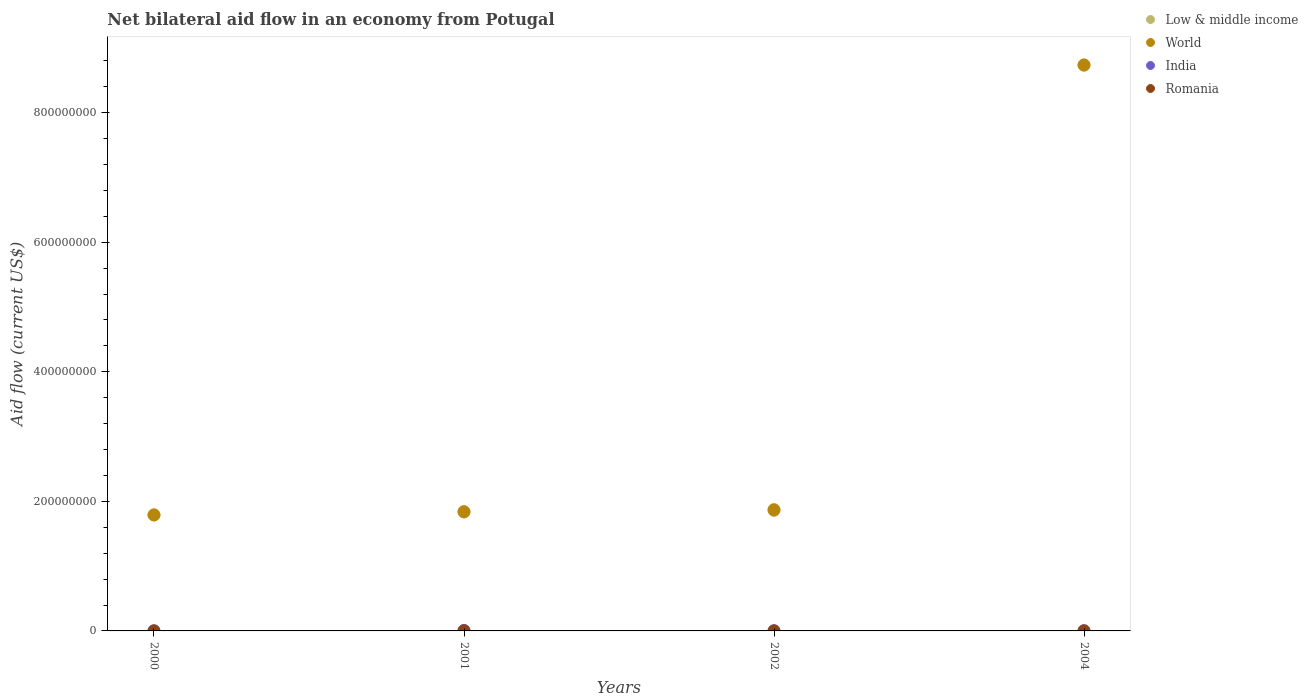How many different coloured dotlines are there?
Your answer should be compact. 4. Is the number of dotlines equal to the number of legend labels?
Provide a short and direct response. Yes. What is the net bilateral aid flow in Romania in 2001?
Your response must be concise. 1.20e+05. Across all years, what is the maximum net bilateral aid flow in Romania?
Offer a terse response. 1.20e+05. Across all years, what is the minimum net bilateral aid flow in Low & middle income?
Make the answer very short. 1.79e+08. In which year was the net bilateral aid flow in Low & middle income maximum?
Provide a short and direct response. 2004. In which year was the net bilateral aid flow in World minimum?
Your response must be concise. 2000. What is the total net bilateral aid flow in World in the graph?
Keep it short and to the point. 1.42e+09. What is the difference between the net bilateral aid flow in India in 2001 and that in 2002?
Ensure brevity in your answer.  5.40e+05. What is the difference between the net bilateral aid flow in India in 2004 and the net bilateral aid flow in Low & middle income in 2001?
Ensure brevity in your answer.  -1.83e+08. What is the average net bilateral aid flow in Low & middle income per year?
Offer a very short reply. 3.55e+08. In the year 2000, what is the difference between the net bilateral aid flow in World and net bilateral aid flow in Romania?
Your answer should be compact. 1.79e+08. In how many years, is the net bilateral aid flow in World greater than 240000000 US$?
Your answer should be compact. 1. What is the ratio of the net bilateral aid flow in Low & middle income in 2001 to that in 2004?
Your response must be concise. 0.21. Is the net bilateral aid flow in Romania in 2000 less than that in 2002?
Offer a terse response. Yes. What is the difference between the highest and the second highest net bilateral aid flow in Low & middle income?
Ensure brevity in your answer.  6.87e+08. What is the difference between the highest and the lowest net bilateral aid flow in Low & middle income?
Offer a terse response. 6.94e+08. How many years are there in the graph?
Keep it short and to the point. 4. Are the values on the major ticks of Y-axis written in scientific E-notation?
Ensure brevity in your answer.  No. Does the graph contain grids?
Offer a terse response. No. Where does the legend appear in the graph?
Keep it short and to the point. Top right. How many legend labels are there?
Make the answer very short. 4. How are the legend labels stacked?
Provide a short and direct response. Vertical. What is the title of the graph?
Provide a succinct answer. Net bilateral aid flow in an economy from Potugal. Does "Malaysia" appear as one of the legend labels in the graph?
Your answer should be very brief. No. What is the label or title of the Y-axis?
Ensure brevity in your answer.  Aid flow (current US$). What is the Aid flow (current US$) of Low & middle income in 2000?
Provide a succinct answer. 1.79e+08. What is the Aid flow (current US$) of World in 2000?
Offer a very short reply. 1.79e+08. What is the Aid flow (current US$) in India in 2000?
Provide a short and direct response. 2.40e+05. What is the Aid flow (current US$) in Low & middle income in 2001?
Give a very brief answer. 1.83e+08. What is the Aid flow (current US$) of World in 2001?
Ensure brevity in your answer.  1.84e+08. What is the Aid flow (current US$) of India in 2001?
Keep it short and to the point. 7.80e+05. What is the Aid flow (current US$) in Romania in 2001?
Ensure brevity in your answer.  1.20e+05. What is the Aid flow (current US$) in Low & middle income in 2002?
Your response must be concise. 1.86e+08. What is the Aid flow (current US$) of World in 2002?
Give a very brief answer. 1.87e+08. What is the Aid flow (current US$) of Low & middle income in 2004?
Keep it short and to the point. 8.73e+08. What is the Aid flow (current US$) of World in 2004?
Offer a very short reply. 8.74e+08. What is the Aid flow (current US$) of India in 2004?
Keep it short and to the point. 2.90e+05. Across all years, what is the maximum Aid flow (current US$) of Low & middle income?
Your response must be concise. 8.73e+08. Across all years, what is the maximum Aid flow (current US$) in World?
Your response must be concise. 8.74e+08. Across all years, what is the maximum Aid flow (current US$) of India?
Make the answer very short. 7.80e+05. Across all years, what is the minimum Aid flow (current US$) in Low & middle income?
Give a very brief answer. 1.79e+08. Across all years, what is the minimum Aid flow (current US$) of World?
Offer a very short reply. 1.79e+08. What is the total Aid flow (current US$) in Low & middle income in the graph?
Make the answer very short. 1.42e+09. What is the total Aid flow (current US$) of World in the graph?
Your response must be concise. 1.42e+09. What is the total Aid flow (current US$) of India in the graph?
Make the answer very short. 1.55e+06. What is the difference between the Aid flow (current US$) of Low & middle income in 2000 and that in 2001?
Provide a short and direct response. -4.56e+06. What is the difference between the Aid flow (current US$) in World in 2000 and that in 2001?
Keep it short and to the point. -4.93e+06. What is the difference between the Aid flow (current US$) of India in 2000 and that in 2001?
Ensure brevity in your answer.  -5.40e+05. What is the difference between the Aid flow (current US$) of Romania in 2000 and that in 2001?
Provide a succinct answer. -8.00e+04. What is the difference between the Aid flow (current US$) in Low & middle income in 2000 and that in 2002?
Offer a very short reply. -7.20e+06. What is the difference between the Aid flow (current US$) in World in 2000 and that in 2002?
Ensure brevity in your answer.  -8.00e+06. What is the difference between the Aid flow (current US$) of India in 2000 and that in 2002?
Your answer should be very brief. 0. What is the difference between the Aid flow (current US$) in Low & middle income in 2000 and that in 2004?
Give a very brief answer. -6.94e+08. What is the difference between the Aid flow (current US$) in World in 2000 and that in 2004?
Provide a succinct answer. -6.95e+08. What is the difference between the Aid flow (current US$) in India in 2000 and that in 2004?
Your answer should be very brief. -5.00e+04. What is the difference between the Aid flow (current US$) of Romania in 2000 and that in 2004?
Offer a terse response. -6.00e+04. What is the difference between the Aid flow (current US$) of Low & middle income in 2001 and that in 2002?
Make the answer very short. -2.64e+06. What is the difference between the Aid flow (current US$) in World in 2001 and that in 2002?
Your response must be concise. -3.07e+06. What is the difference between the Aid flow (current US$) in India in 2001 and that in 2002?
Your answer should be very brief. 5.40e+05. What is the difference between the Aid flow (current US$) in Romania in 2001 and that in 2002?
Make the answer very short. 2.00e+04. What is the difference between the Aid flow (current US$) of Low & middle income in 2001 and that in 2004?
Offer a very short reply. -6.90e+08. What is the difference between the Aid flow (current US$) in World in 2001 and that in 2004?
Provide a short and direct response. -6.90e+08. What is the difference between the Aid flow (current US$) in India in 2001 and that in 2004?
Offer a very short reply. 4.90e+05. What is the difference between the Aid flow (current US$) in Low & middle income in 2002 and that in 2004?
Your answer should be compact. -6.87e+08. What is the difference between the Aid flow (current US$) of World in 2002 and that in 2004?
Your answer should be very brief. -6.87e+08. What is the difference between the Aid flow (current US$) in India in 2002 and that in 2004?
Offer a terse response. -5.00e+04. What is the difference between the Aid flow (current US$) in Low & middle income in 2000 and the Aid flow (current US$) in World in 2001?
Provide a short and direct response. -5.21e+06. What is the difference between the Aid flow (current US$) in Low & middle income in 2000 and the Aid flow (current US$) in India in 2001?
Provide a short and direct response. 1.78e+08. What is the difference between the Aid flow (current US$) in Low & middle income in 2000 and the Aid flow (current US$) in Romania in 2001?
Offer a very short reply. 1.79e+08. What is the difference between the Aid flow (current US$) in World in 2000 and the Aid flow (current US$) in India in 2001?
Keep it short and to the point. 1.78e+08. What is the difference between the Aid flow (current US$) in World in 2000 and the Aid flow (current US$) in Romania in 2001?
Offer a very short reply. 1.79e+08. What is the difference between the Aid flow (current US$) of India in 2000 and the Aid flow (current US$) of Romania in 2001?
Provide a short and direct response. 1.20e+05. What is the difference between the Aid flow (current US$) of Low & middle income in 2000 and the Aid flow (current US$) of World in 2002?
Keep it short and to the point. -8.28e+06. What is the difference between the Aid flow (current US$) of Low & middle income in 2000 and the Aid flow (current US$) of India in 2002?
Your response must be concise. 1.79e+08. What is the difference between the Aid flow (current US$) in Low & middle income in 2000 and the Aid flow (current US$) in Romania in 2002?
Your answer should be compact. 1.79e+08. What is the difference between the Aid flow (current US$) in World in 2000 and the Aid flow (current US$) in India in 2002?
Offer a very short reply. 1.79e+08. What is the difference between the Aid flow (current US$) in World in 2000 and the Aid flow (current US$) in Romania in 2002?
Make the answer very short. 1.79e+08. What is the difference between the Aid flow (current US$) in India in 2000 and the Aid flow (current US$) in Romania in 2002?
Keep it short and to the point. 1.40e+05. What is the difference between the Aid flow (current US$) in Low & middle income in 2000 and the Aid flow (current US$) in World in 2004?
Your answer should be compact. -6.95e+08. What is the difference between the Aid flow (current US$) of Low & middle income in 2000 and the Aid flow (current US$) of India in 2004?
Provide a short and direct response. 1.79e+08. What is the difference between the Aid flow (current US$) in Low & middle income in 2000 and the Aid flow (current US$) in Romania in 2004?
Keep it short and to the point. 1.79e+08. What is the difference between the Aid flow (current US$) of World in 2000 and the Aid flow (current US$) of India in 2004?
Offer a very short reply. 1.79e+08. What is the difference between the Aid flow (current US$) in World in 2000 and the Aid flow (current US$) in Romania in 2004?
Ensure brevity in your answer.  1.79e+08. What is the difference between the Aid flow (current US$) of Low & middle income in 2001 and the Aid flow (current US$) of World in 2002?
Keep it short and to the point. -3.72e+06. What is the difference between the Aid flow (current US$) in Low & middle income in 2001 and the Aid flow (current US$) in India in 2002?
Your answer should be compact. 1.83e+08. What is the difference between the Aid flow (current US$) of Low & middle income in 2001 and the Aid flow (current US$) of Romania in 2002?
Provide a short and direct response. 1.83e+08. What is the difference between the Aid flow (current US$) of World in 2001 and the Aid flow (current US$) of India in 2002?
Your response must be concise. 1.84e+08. What is the difference between the Aid flow (current US$) of World in 2001 and the Aid flow (current US$) of Romania in 2002?
Provide a short and direct response. 1.84e+08. What is the difference between the Aid flow (current US$) of India in 2001 and the Aid flow (current US$) of Romania in 2002?
Your answer should be compact. 6.80e+05. What is the difference between the Aid flow (current US$) of Low & middle income in 2001 and the Aid flow (current US$) of World in 2004?
Your answer should be compact. -6.90e+08. What is the difference between the Aid flow (current US$) in Low & middle income in 2001 and the Aid flow (current US$) in India in 2004?
Offer a very short reply. 1.83e+08. What is the difference between the Aid flow (current US$) of Low & middle income in 2001 and the Aid flow (current US$) of Romania in 2004?
Keep it short and to the point. 1.83e+08. What is the difference between the Aid flow (current US$) in World in 2001 and the Aid flow (current US$) in India in 2004?
Provide a succinct answer. 1.84e+08. What is the difference between the Aid flow (current US$) in World in 2001 and the Aid flow (current US$) in Romania in 2004?
Keep it short and to the point. 1.84e+08. What is the difference between the Aid flow (current US$) in India in 2001 and the Aid flow (current US$) in Romania in 2004?
Keep it short and to the point. 6.80e+05. What is the difference between the Aid flow (current US$) of Low & middle income in 2002 and the Aid flow (current US$) of World in 2004?
Make the answer very short. -6.88e+08. What is the difference between the Aid flow (current US$) in Low & middle income in 2002 and the Aid flow (current US$) in India in 2004?
Your answer should be very brief. 1.86e+08. What is the difference between the Aid flow (current US$) of Low & middle income in 2002 and the Aid flow (current US$) of Romania in 2004?
Ensure brevity in your answer.  1.86e+08. What is the difference between the Aid flow (current US$) in World in 2002 and the Aid flow (current US$) in India in 2004?
Your answer should be very brief. 1.87e+08. What is the difference between the Aid flow (current US$) of World in 2002 and the Aid flow (current US$) of Romania in 2004?
Offer a terse response. 1.87e+08. What is the average Aid flow (current US$) of Low & middle income per year?
Your answer should be very brief. 3.55e+08. What is the average Aid flow (current US$) in World per year?
Keep it short and to the point. 3.56e+08. What is the average Aid flow (current US$) in India per year?
Your response must be concise. 3.88e+05. In the year 2000, what is the difference between the Aid flow (current US$) of Low & middle income and Aid flow (current US$) of World?
Keep it short and to the point. -2.80e+05. In the year 2000, what is the difference between the Aid flow (current US$) in Low & middle income and Aid flow (current US$) in India?
Your answer should be very brief. 1.79e+08. In the year 2000, what is the difference between the Aid flow (current US$) of Low & middle income and Aid flow (current US$) of Romania?
Your answer should be very brief. 1.79e+08. In the year 2000, what is the difference between the Aid flow (current US$) of World and Aid flow (current US$) of India?
Give a very brief answer. 1.79e+08. In the year 2000, what is the difference between the Aid flow (current US$) in World and Aid flow (current US$) in Romania?
Your response must be concise. 1.79e+08. In the year 2000, what is the difference between the Aid flow (current US$) of India and Aid flow (current US$) of Romania?
Your answer should be compact. 2.00e+05. In the year 2001, what is the difference between the Aid flow (current US$) in Low & middle income and Aid flow (current US$) in World?
Your answer should be very brief. -6.50e+05. In the year 2001, what is the difference between the Aid flow (current US$) in Low & middle income and Aid flow (current US$) in India?
Give a very brief answer. 1.83e+08. In the year 2001, what is the difference between the Aid flow (current US$) in Low & middle income and Aid flow (current US$) in Romania?
Ensure brevity in your answer.  1.83e+08. In the year 2001, what is the difference between the Aid flow (current US$) of World and Aid flow (current US$) of India?
Keep it short and to the point. 1.83e+08. In the year 2001, what is the difference between the Aid flow (current US$) of World and Aid flow (current US$) of Romania?
Your response must be concise. 1.84e+08. In the year 2002, what is the difference between the Aid flow (current US$) in Low & middle income and Aid flow (current US$) in World?
Provide a succinct answer. -1.08e+06. In the year 2002, what is the difference between the Aid flow (current US$) in Low & middle income and Aid flow (current US$) in India?
Keep it short and to the point. 1.86e+08. In the year 2002, what is the difference between the Aid flow (current US$) in Low & middle income and Aid flow (current US$) in Romania?
Provide a short and direct response. 1.86e+08. In the year 2002, what is the difference between the Aid flow (current US$) of World and Aid flow (current US$) of India?
Your answer should be compact. 1.87e+08. In the year 2002, what is the difference between the Aid flow (current US$) in World and Aid flow (current US$) in Romania?
Make the answer very short. 1.87e+08. In the year 2002, what is the difference between the Aid flow (current US$) of India and Aid flow (current US$) of Romania?
Give a very brief answer. 1.40e+05. In the year 2004, what is the difference between the Aid flow (current US$) of Low & middle income and Aid flow (current US$) of World?
Give a very brief answer. -6.30e+05. In the year 2004, what is the difference between the Aid flow (current US$) in Low & middle income and Aid flow (current US$) in India?
Ensure brevity in your answer.  8.73e+08. In the year 2004, what is the difference between the Aid flow (current US$) in Low & middle income and Aid flow (current US$) in Romania?
Ensure brevity in your answer.  8.73e+08. In the year 2004, what is the difference between the Aid flow (current US$) in World and Aid flow (current US$) in India?
Provide a short and direct response. 8.74e+08. In the year 2004, what is the difference between the Aid flow (current US$) in World and Aid flow (current US$) in Romania?
Provide a short and direct response. 8.74e+08. What is the ratio of the Aid flow (current US$) in Low & middle income in 2000 to that in 2001?
Your answer should be very brief. 0.98. What is the ratio of the Aid flow (current US$) in World in 2000 to that in 2001?
Offer a terse response. 0.97. What is the ratio of the Aid flow (current US$) of India in 2000 to that in 2001?
Make the answer very short. 0.31. What is the ratio of the Aid flow (current US$) in Low & middle income in 2000 to that in 2002?
Your answer should be compact. 0.96. What is the ratio of the Aid flow (current US$) in World in 2000 to that in 2002?
Keep it short and to the point. 0.96. What is the ratio of the Aid flow (current US$) of India in 2000 to that in 2002?
Your answer should be compact. 1. What is the ratio of the Aid flow (current US$) in Romania in 2000 to that in 2002?
Offer a very short reply. 0.4. What is the ratio of the Aid flow (current US$) of Low & middle income in 2000 to that in 2004?
Offer a very short reply. 0.2. What is the ratio of the Aid flow (current US$) of World in 2000 to that in 2004?
Your answer should be compact. 0.2. What is the ratio of the Aid flow (current US$) in India in 2000 to that in 2004?
Provide a short and direct response. 0.83. What is the ratio of the Aid flow (current US$) of Romania in 2000 to that in 2004?
Offer a very short reply. 0.4. What is the ratio of the Aid flow (current US$) in Low & middle income in 2001 to that in 2002?
Offer a terse response. 0.99. What is the ratio of the Aid flow (current US$) of World in 2001 to that in 2002?
Give a very brief answer. 0.98. What is the ratio of the Aid flow (current US$) in Romania in 2001 to that in 2002?
Offer a very short reply. 1.2. What is the ratio of the Aid flow (current US$) in Low & middle income in 2001 to that in 2004?
Your answer should be compact. 0.21. What is the ratio of the Aid flow (current US$) of World in 2001 to that in 2004?
Give a very brief answer. 0.21. What is the ratio of the Aid flow (current US$) of India in 2001 to that in 2004?
Offer a terse response. 2.69. What is the ratio of the Aid flow (current US$) in Romania in 2001 to that in 2004?
Offer a very short reply. 1.2. What is the ratio of the Aid flow (current US$) of Low & middle income in 2002 to that in 2004?
Offer a terse response. 0.21. What is the ratio of the Aid flow (current US$) in World in 2002 to that in 2004?
Make the answer very short. 0.21. What is the ratio of the Aid flow (current US$) of India in 2002 to that in 2004?
Keep it short and to the point. 0.83. What is the difference between the highest and the second highest Aid flow (current US$) in Low & middle income?
Offer a terse response. 6.87e+08. What is the difference between the highest and the second highest Aid flow (current US$) in World?
Your response must be concise. 6.87e+08. What is the difference between the highest and the second highest Aid flow (current US$) in India?
Offer a very short reply. 4.90e+05. What is the difference between the highest and the second highest Aid flow (current US$) of Romania?
Provide a short and direct response. 2.00e+04. What is the difference between the highest and the lowest Aid flow (current US$) of Low & middle income?
Make the answer very short. 6.94e+08. What is the difference between the highest and the lowest Aid flow (current US$) in World?
Ensure brevity in your answer.  6.95e+08. What is the difference between the highest and the lowest Aid flow (current US$) of India?
Provide a succinct answer. 5.40e+05. What is the difference between the highest and the lowest Aid flow (current US$) in Romania?
Offer a terse response. 8.00e+04. 